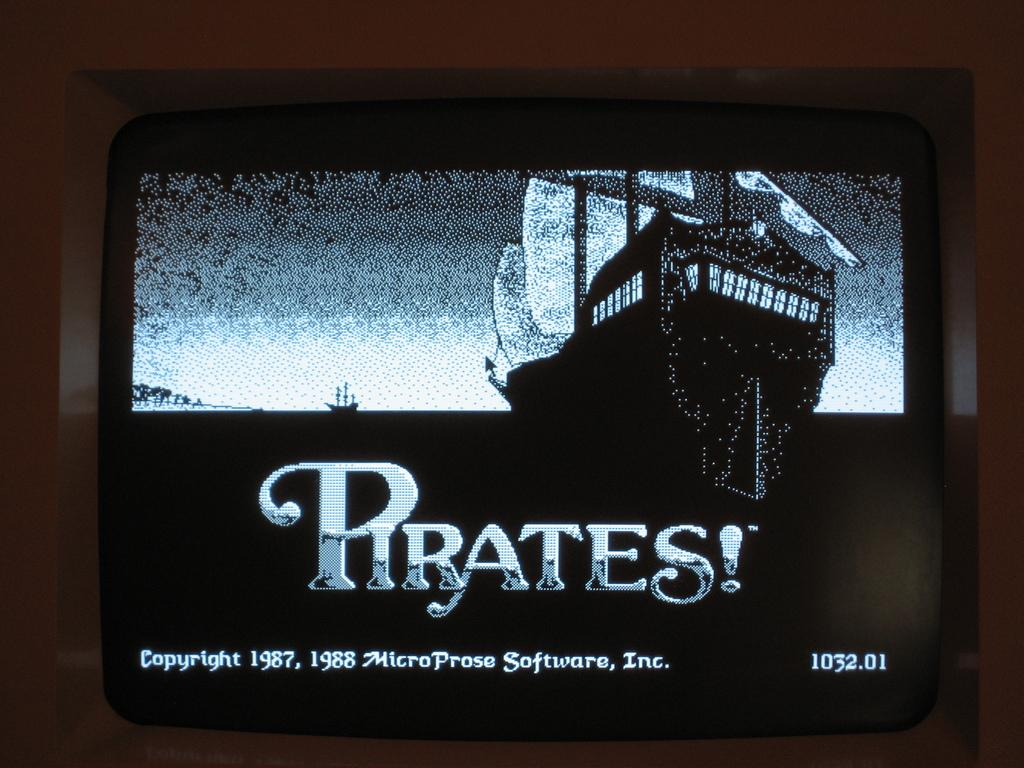<image>
Render a clear and concise summary of the photo. A game called Pirates! with the copyright of 1987. 